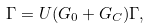Convert formula to latex. <formula><loc_0><loc_0><loc_500><loc_500>\Gamma = U ( G _ { 0 } + G _ { C } ) \Gamma ,</formula> 